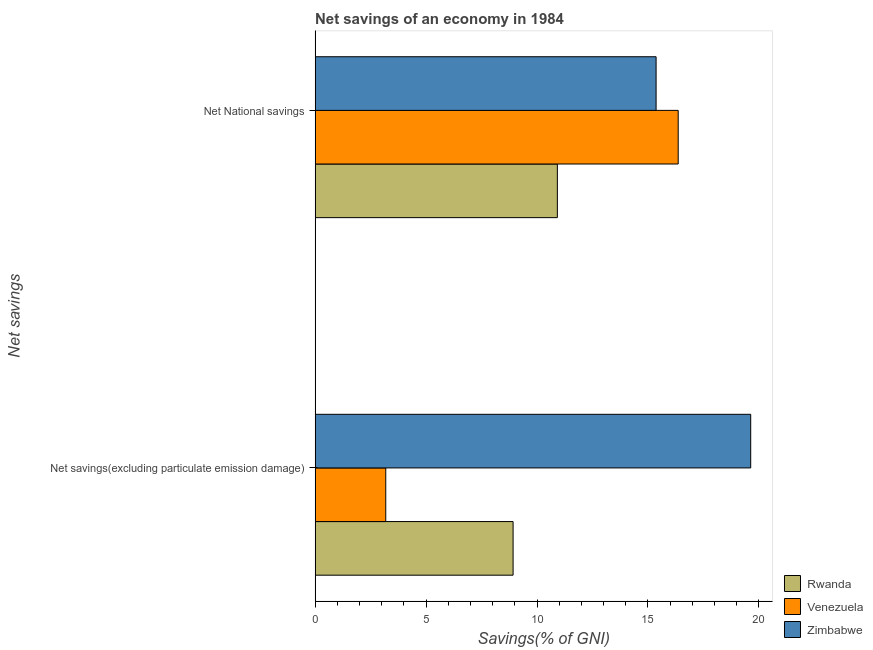How many groups of bars are there?
Your answer should be compact. 2. Are the number of bars per tick equal to the number of legend labels?
Offer a very short reply. Yes. Are the number of bars on each tick of the Y-axis equal?
Provide a succinct answer. Yes. How many bars are there on the 2nd tick from the top?
Ensure brevity in your answer.  3. How many bars are there on the 1st tick from the bottom?
Keep it short and to the point. 3. What is the label of the 2nd group of bars from the top?
Make the answer very short. Net savings(excluding particulate emission damage). What is the net national savings in Venezuela?
Offer a terse response. 16.36. Across all countries, what is the maximum net savings(excluding particulate emission damage)?
Your response must be concise. 19.63. Across all countries, what is the minimum net savings(excluding particulate emission damage)?
Your response must be concise. 3.18. In which country was the net savings(excluding particulate emission damage) maximum?
Your response must be concise. Zimbabwe. In which country was the net national savings minimum?
Offer a terse response. Rwanda. What is the total net savings(excluding particulate emission damage) in the graph?
Keep it short and to the point. 31.74. What is the difference between the net savings(excluding particulate emission damage) in Venezuela and that in Zimbabwe?
Offer a very short reply. -16.44. What is the difference between the net savings(excluding particulate emission damage) in Zimbabwe and the net national savings in Venezuela?
Ensure brevity in your answer.  3.27. What is the average net savings(excluding particulate emission damage) per country?
Ensure brevity in your answer.  10.58. What is the difference between the net savings(excluding particulate emission damage) and net national savings in Rwanda?
Your answer should be compact. -1.99. In how many countries, is the net national savings greater than 5 %?
Ensure brevity in your answer.  3. What is the ratio of the net national savings in Venezuela to that in Rwanda?
Your answer should be compact. 1.5. What does the 3rd bar from the top in Net National savings represents?
Your response must be concise. Rwanda. What does the 3rd bar from the bottom in Net savings(excluding particulate emission damage) represents?
Provide a short and direct response. Zimbabwe. How many bars are there?
Ensure brevity in your answer.  6. Are all the bars in the graph horizontal?
Ensure brevity in your answer.  Yes. What is the difference between two consecutive major ticks on the X-axis?
Provide a short and direct response. 5. How many legend labels are there?
Your answer should be compact. 3. How are the legend labels stacked?
Your answer should be compact. Vertical. What is the title of the graph?
Make the answer very short. Net savings of an economy in 1984. Does "Vanuatu" appear as one of the legend labels in the graph?
Offer a terse response. No. What is the label or title of the X-axis?
Offer a very short reply. Savings(% of GNI). What is the label or title of the Y-axis?
Offer a very short reply. Net savings. What is the Savings(% of GNI) of Rwanda in Net savings(excluding particulate emission damage)?
Your answer should be compact. 8.92. What is the Savings(% of GNI) of Venezuela in Net savings(excluding particulate emission damage)?
Keep it short and to the point. 3.18. What is the Savings(% of GNI) of Zimbabwe in Net savings(excluding particulate emission damage)?
Make the answer very short. 19.63. What is the Savings(% of GNI) of Rwanda in Net National savings?
Give a very brief answer. 10.92. What is the Savings(% of GNI) in Venezuela in Net National savings?
Provide a succinct answer. 16.36. What is the Savings(% of GNI) of Zimbabwe in Net National savings?
Make the answer very short. 15.37. Across all Net savings, what is the maximum Savings(% of GNI) in Rwanda?
Offer a terse response. 10.92. Across all Net savings, what is the maximum Savings(% of GNI) of Venezuela?
Give a very brief answer. 16.36. Across all Net savings, what is the maximum Savings(% of GNI) in Zimbabwe?
Ensure brevity in your answer.  19.63. Across all Net savings, what is the minimum Savings(% of GNI) in Rwanda?
Your response must be concise. 8.92. Across all Net savings, what is the minimum Savings(% of GNI) of Venezuela?
Your answer should be compact. 3.18. Across all Net savings, what is the minimum Savings(% of GNI) in Zimbabwe?
Your response must be concise. 15.37. What is the total Savings(% of GNI) in Rwanda in the graph?
Offer a very short reply. 19.84. What is the total Savings(% of GNI) of Venezuela in the graph?
Offer a very short reply. 19.55. What is the total Savings(% of GNI) in Zimbabwe in the graph?
Your answer should be compact. 35. What is the difference between the Savings(% of GNI) of Rwanda in Net savings(excluding particulate emission damage) and that in Net National savings?
Keep it short and to the point. -1.99. What is the difference between the Savings(% of GNI) of Venezuela in Net savings(excluding particulate emission damage) and that in Net National savings?
Offer a terse response. -13.18. What is the difference between the Savings(% of GNI) of Zimbabwe in Net savings(excluding particulate emission damage) and that in Net National savings?
Your answer should be compact. 4.26. What is the difference between the Savings(% of GNI) in Rwanda in Net savings(excluding particulate emission damage) and the Savings(% of GNI) in Venezuela in Net National savings?
Your answer should be very brief. -7.44. What is the difference between the Savings(% of GNI) of Rwanda in Net savings(excluding particulate emission damage) and the Savings(% of GNI) of Zimbabwe in Net National savings?
Offer a very short reply. -6.44. What is the difference between the Savings(% of GNI) in Venezuela in Net savings(excluding particulate emission damage) and the Savings(% of GNI) in Zimbabwe in Net National savings?
Keep it short and to the point. -12.18. What is the average Savings(% of GNI) of Rwanda per Net savings?
Provide a succinct answer. 9.92. What is the average Savings(% of GNI) of Venezuela per Net savings?
Keep it short and to the point. 9.77. What is the average Savings(% of GNI) of Zimbabwe per Net savings?
Your answer should be very brief. 17.5. What is the difference between the Savings(% of GNI) in Rwanda and Savings(% of GNI) in Venezuela in Net savings(excluding particulate emission damage)?
Your answer should be very brief. 5.74. What is the difference between the Savings(% of GNI) in Rwanda and Savings(% of GNI) in Zimbabwe in Net savings(excluding particulate emission damage)?
Offer a terse response. -10.71. What is the difference between the Savings(% of GNI) of Venezuela and Savings(% of GNI) of Zimbabwe in Net savings(excluding particulate emission damage)?
Give a very brief answer. -16.44. What is the difference between the Savings(% of GNI) in Rwanda and Savings(% of GNI) in Venezuela in Net National savings?
Provide a succinct answer. -5.45. What is the difference between the Savings(% of GNI) of Rwanda and Savings(% of GNI) of Zimbabwe in Net National savings?
Your answer should be compact. -4.45. What is the difference between the Savings(% of GNI) in Venezuela and Savings(% of GNI) in Zimbabwe in Net National savings?
Provide a short and direct response. 1. What is the ratio of the Savings(% of GNI) of Rwanda in Net savings(excluding particulate emission damage) to that in Net National savings?
Provide a short and direct response. 0.82. What is the ratio of the Savings(% of GNI) in Venezuela in Net savings(excluding particulate emission damage) to that in Net National savings?
Keep it short and to the point. 0.19. What is the ratio of the Savings(% of GNI) of Zimbabwe in Net savings(excluding particulate emission damage) to that in Net National savings?
Make the answer very short. 1.28. What is the difference between the highest and the second highest Savings(% of GNI) in Rwanda?
Give a very brief answer. 1.99. What is the difference between the highest and the second highest Savings(% of GNI) in Venezuela?
Offer a terse response. 13.18. What is the difference between the highest and the second highest Savings(% of GNI) of Zimbabwe?
Make the answer very short. 4.26. What is the difference between the highest and the lowest Savings(% of GNI) of Rwanda?
Provide a succinct answer. 1.99. What is the difference between the highest and the lowest Savings(% of GNI) of Venezuela?
Offer a terse response. 13.18. What is the difference between the highest and the lowest Savings(% of GNI) in Zimbabwe?
Give a very brief answer. 4.26. 